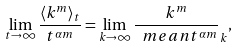Convert formula to latex. <formula><loc_0><loc_0><loc_500><loc_500>\lim _ { t \to \infty } \frac { \langle k ^ { m } \rangle _ { t } } { t ^ { \alpha m } } = \lim _ { k \to \infty } \frac { k ^ { m } } { \ m e a n { t ^ { \alpha m } } } _ { k } ,</formula> 